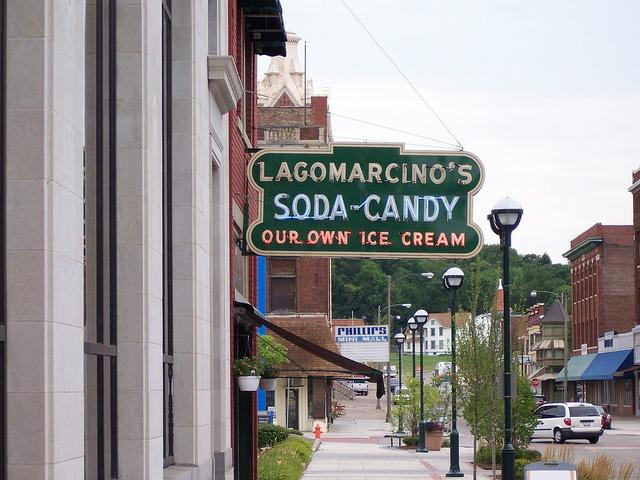What product is made at and for Lagomarcino's? ice cream 